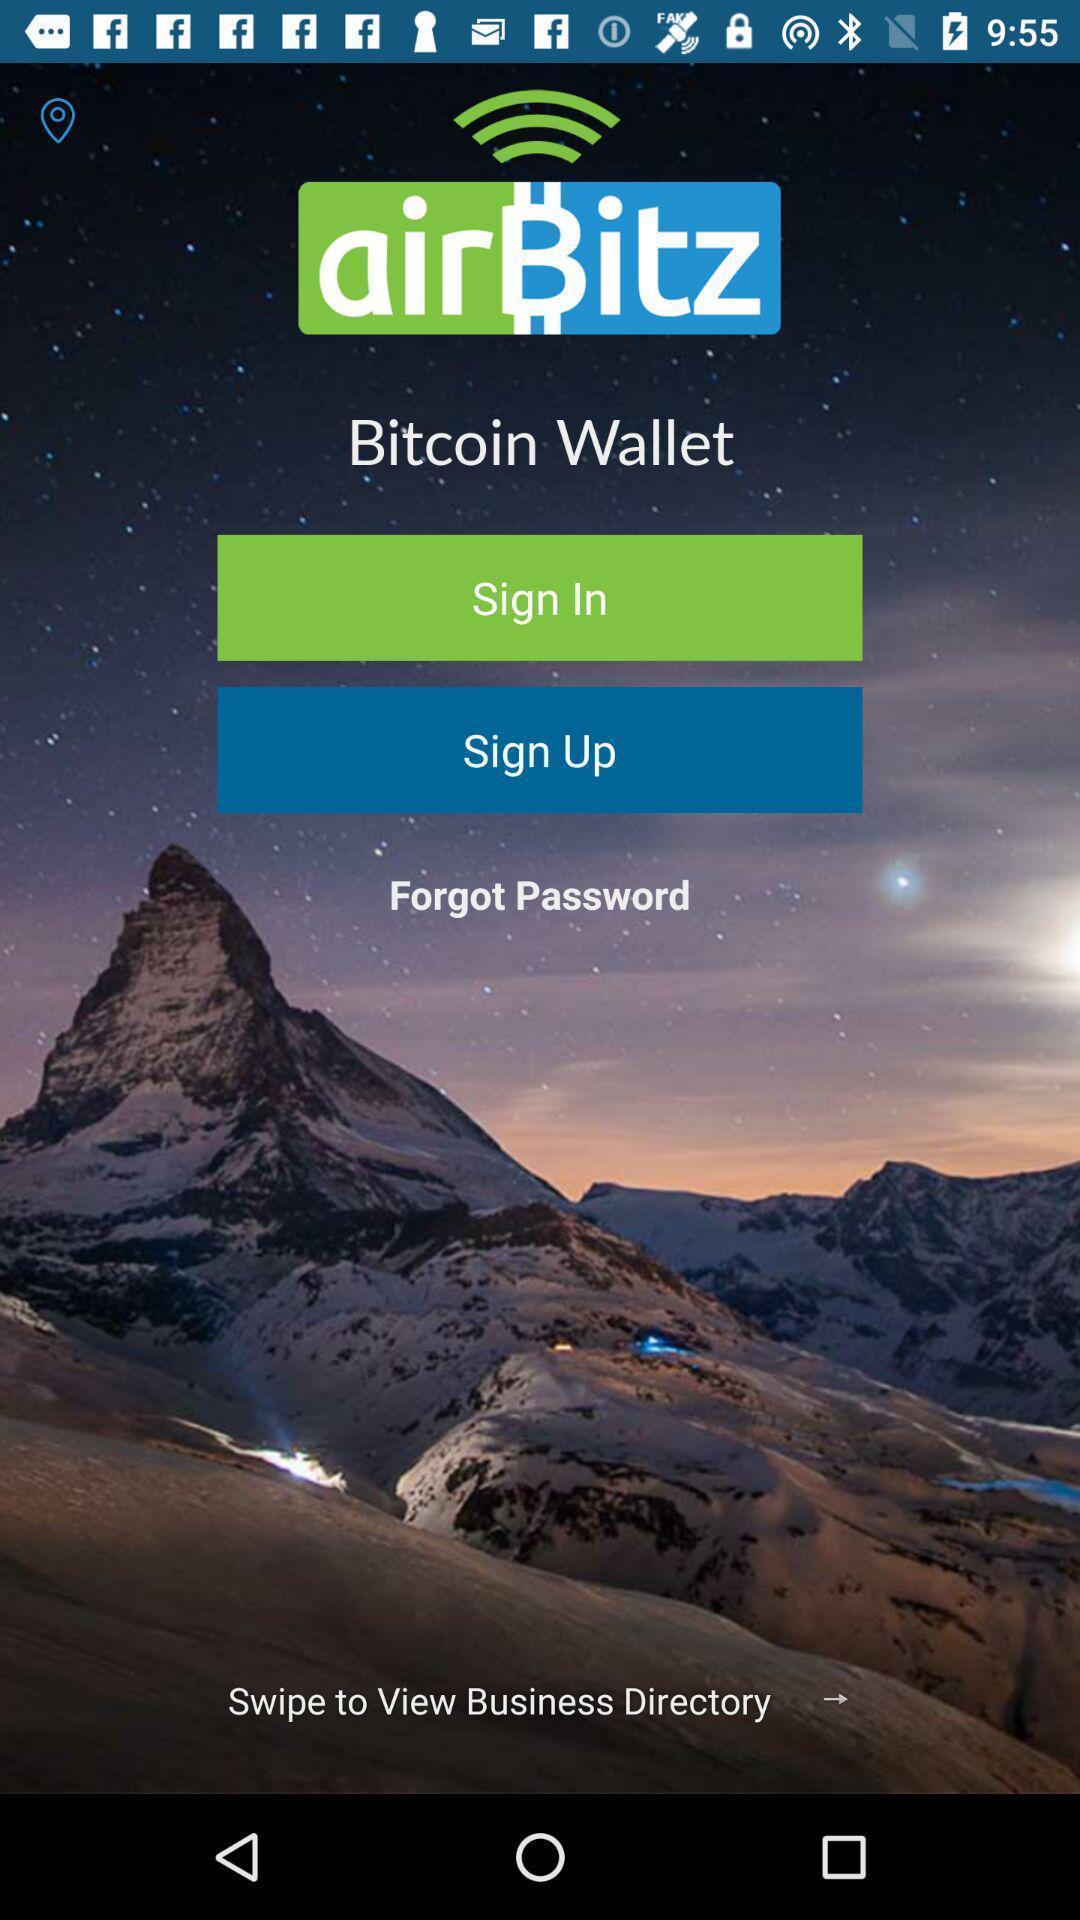Describe the key features of this screenshot. Sign-in page of a finance app. 